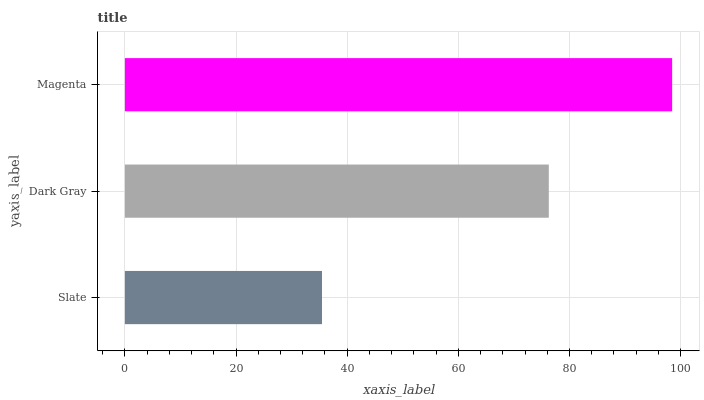Is Slate the minimum?
Answer yes or no. Yes. Is Magenta the maximum?
Answer yes or no. Yes. Is Dark Gray the minimum?
Answer yes or no. No. Is Dark Gray the maximum?
Answer yes or no. No. Is Dark Gray greater than Slate?
Answer yes or no. Yes. Is Slate less than Dark Gray?
Answer yes or no. Yes. Is Slate greater than Dark Gray?
Answer yes or no. No. Is Dark Gray less than Slate?
Answer yes or no. No. Is Dark Gray the high median?
Answer yes or no. Yes. Is Dark Gray the low median?
Answer yes or no. Yes. Is Magenta the high median?
Answer yes or no. No. Is Slate the low median?
Answer yes or no. No. 